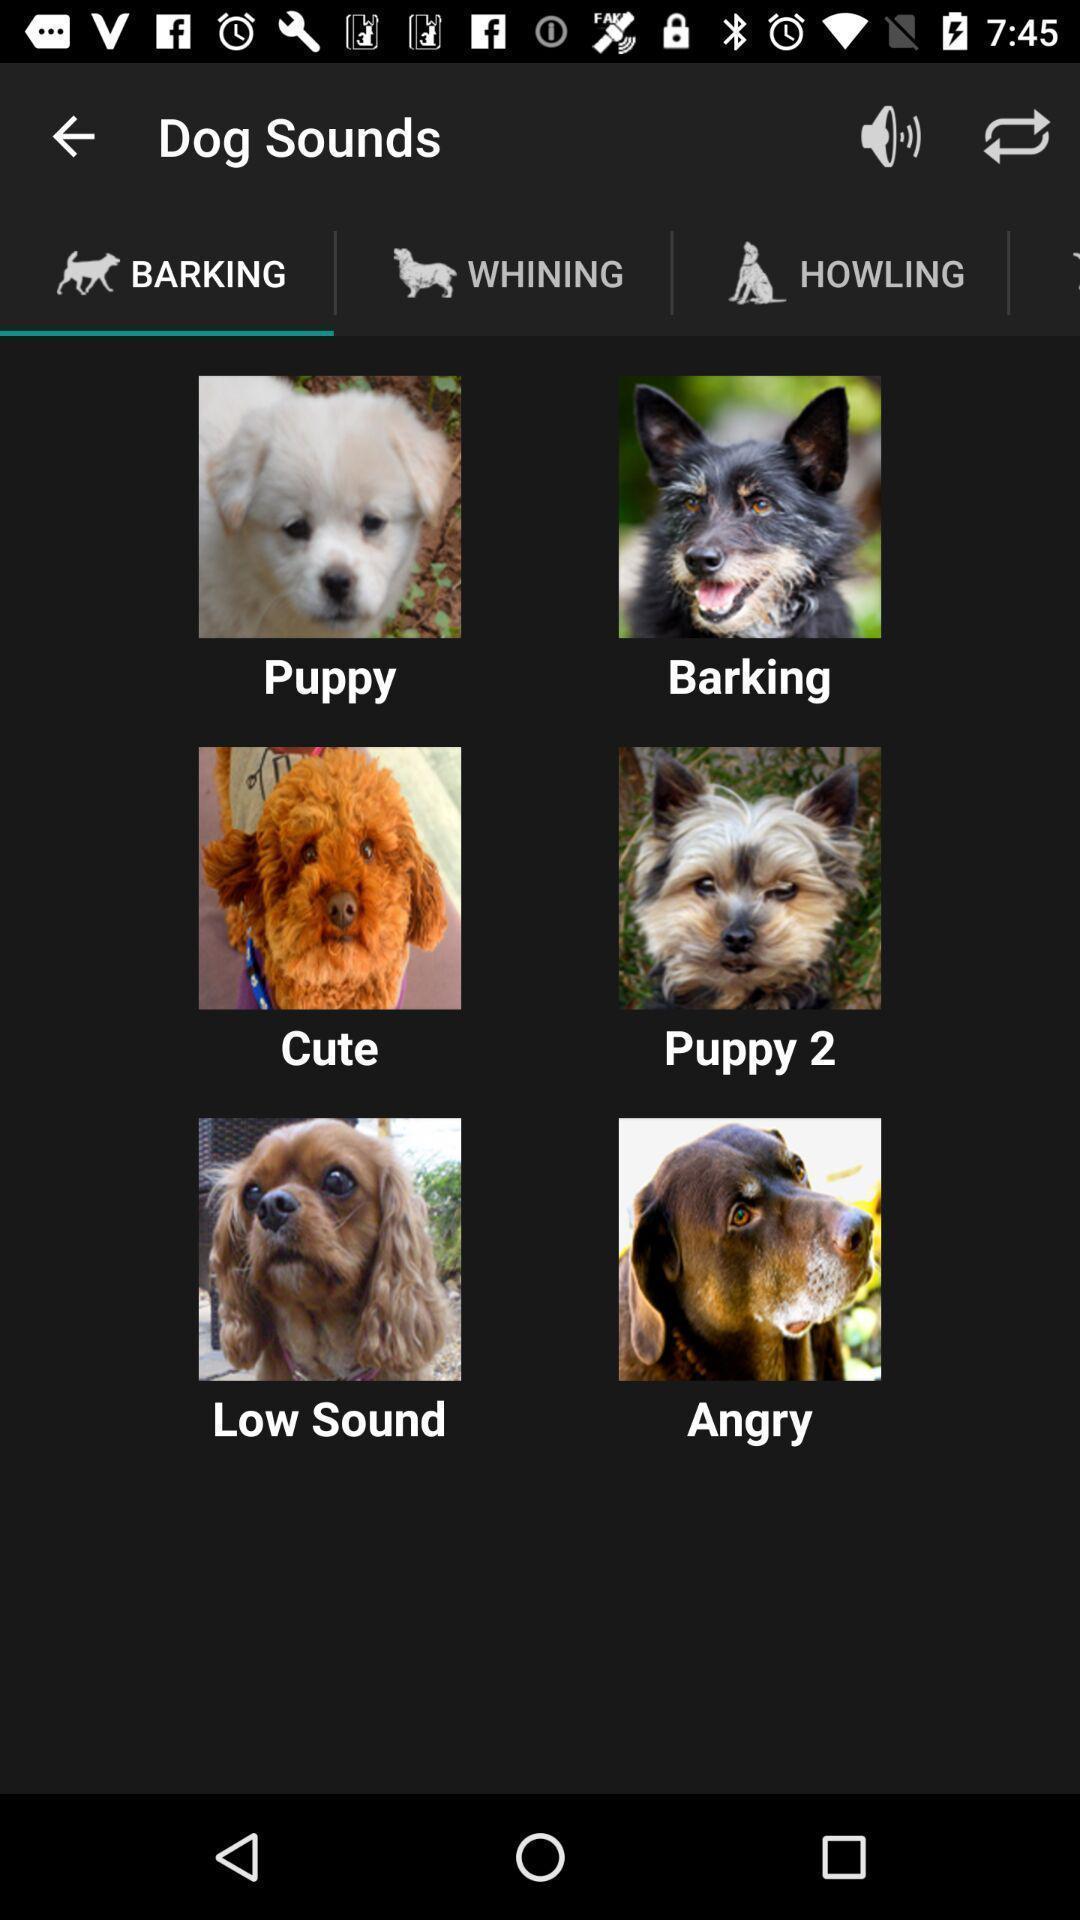What is the overall content of this screenshot? Screen showing expressions of dogs. 